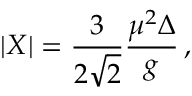<formula> <loc_0><loc_0><loc_500><loc_500>| X | = { \frac { 3 } { 2 \sqrt { 2 } } } { \frac { \mu ^ { 2 } \Delta } { g } } \, ,</formula> 